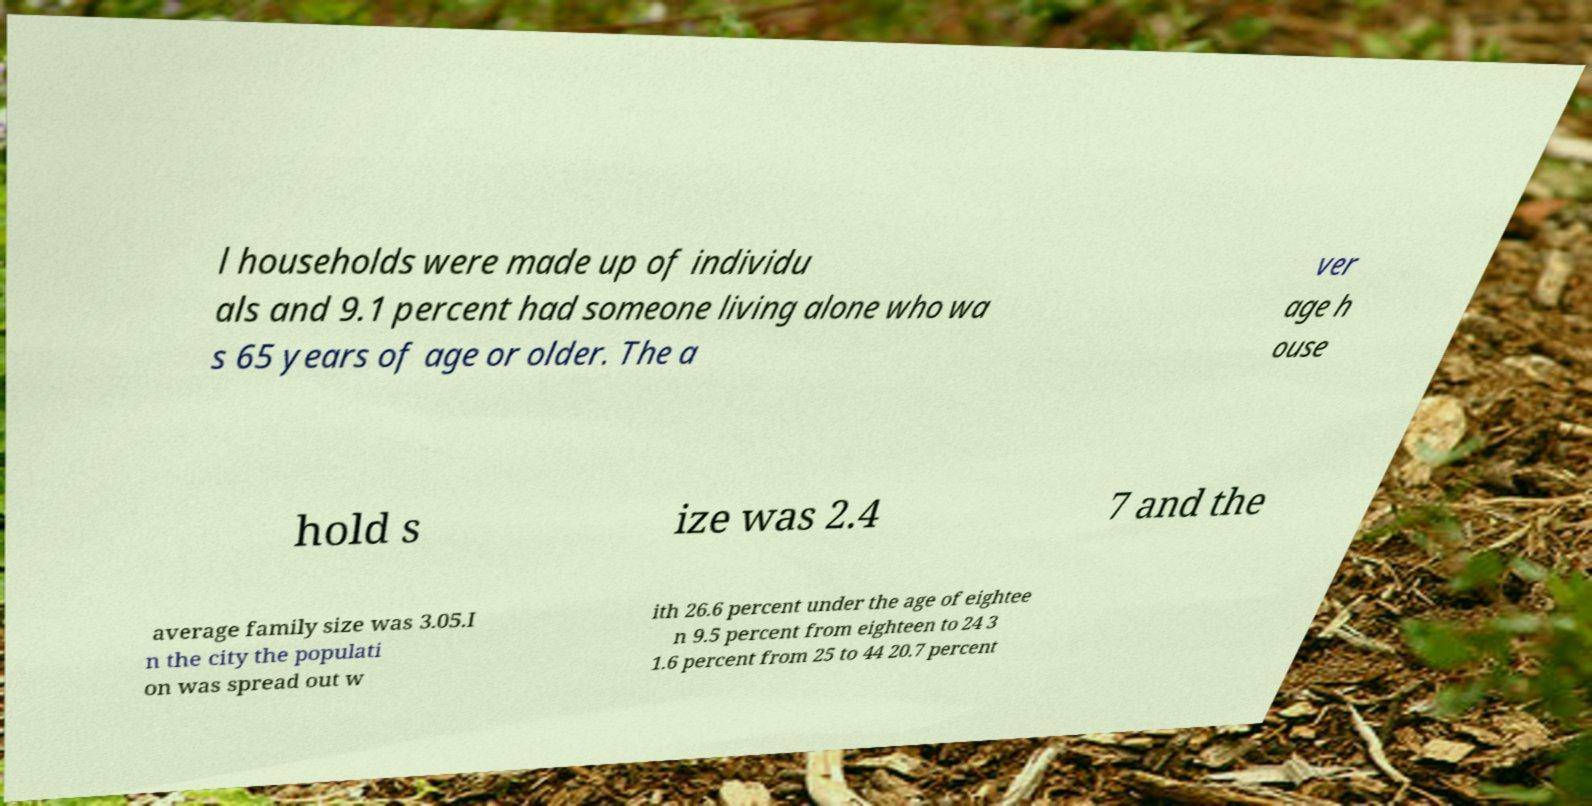Can you read and provide the text displayed in the image?This photo seems to have some interesting text. Can you extract and type it out for me? l households were made up of individu als and 9.1 percent had someone living alone who wa s 65 years of age or older. The a ver age h ouse hold s ize was 2.4 7 and the average family size was 3.05.I n the city the populati on was spread out w ith 26.6 percent under the age of eightee n 9.5 percent from eighteen to 24 3 1.6 percent from 25 to 44 20.7 percent 